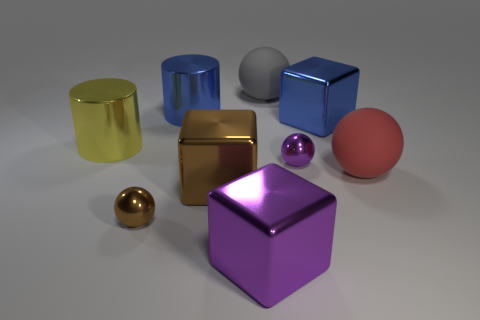Can you describe the lighting in the scene? How does it affect the appearance of the objects? The lighting in the scene appears to be soft and diffused, coming from above. It casts gentle shadows under the objects, enhancing their three-dimensional form without causing harsh glares, and highlights the reflective qualities of the metal surfaces. 